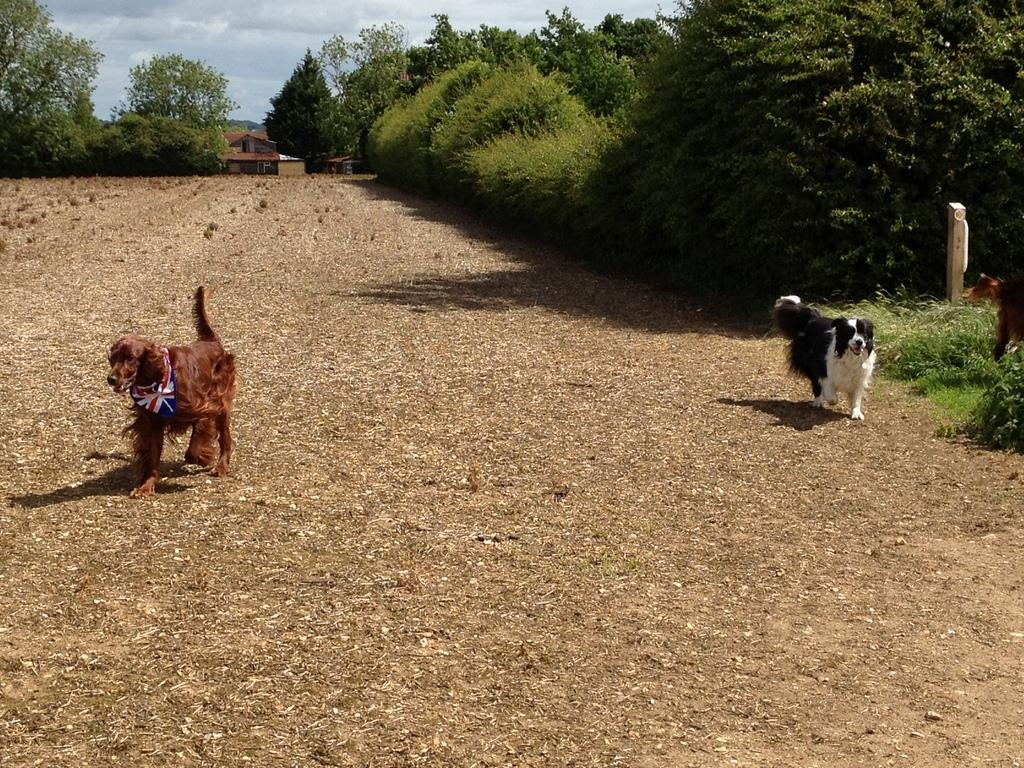How many dogs are in the image? There are two dogs in the image. What are the dogs doing in the image? The dogs are walking on the land. What type of vegetation is on the right side of the image? There is grass, plants, and trees on the right side of the image. Where is the house located in the image? The house is beside some trees in the image. What is visible at the top of the image? The sky is visible at the top of the image. What design is featured on the tax form in the image? There is no tax form present in the image; it features two dogs walking on the land, grass, plants, trees, a house, and the sky. How many clovers can be seen growing in the image? There are no clovers visible in the image. 